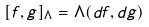<formula> <loc_0><loc_0><loc_500><loc_500>[ f , g ] _ { \Lambda } = \Lambda ( d f , d g )</formula> 